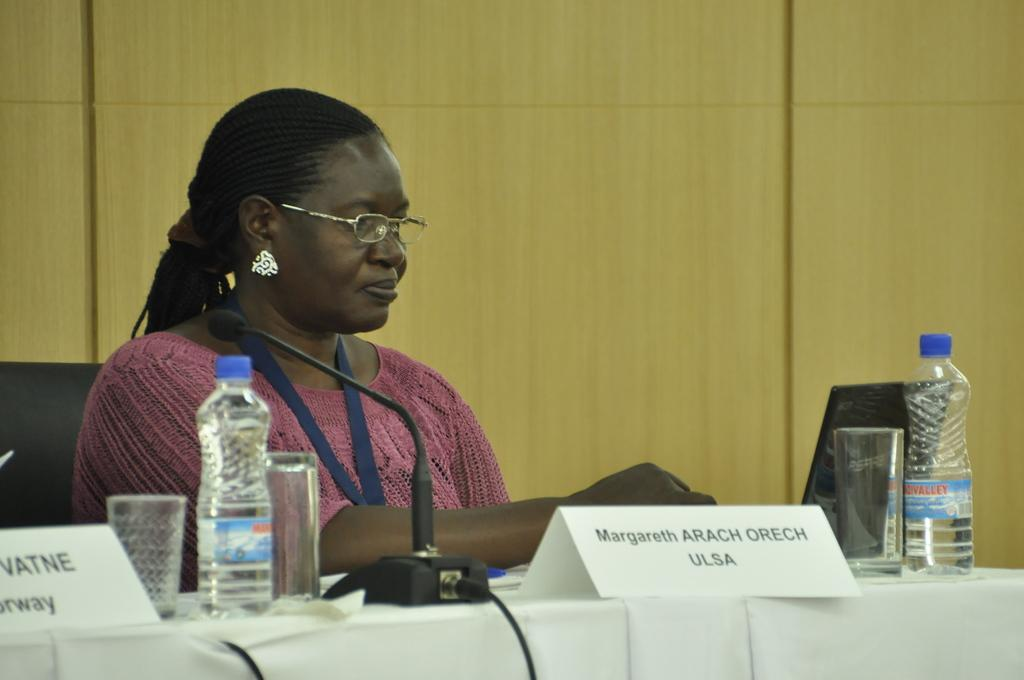Who is the main subject in the image? There is a lady in the image. What is the lady wearing? The lady is wearing a pink dress. What is the lady doing in the image? The lady is sitting on a chair. Where is the chair located in relation to the table? The chair is in front of a table. What items can be seen on the table? There is a name plate, a glass, a bottle, and a microphone (mic) on the table. What type of account can be seen on the table in the image? There is no account present on the table in the image. Can you tell me how many matches are on the table in the image? There are no matches present on the table in the image. 